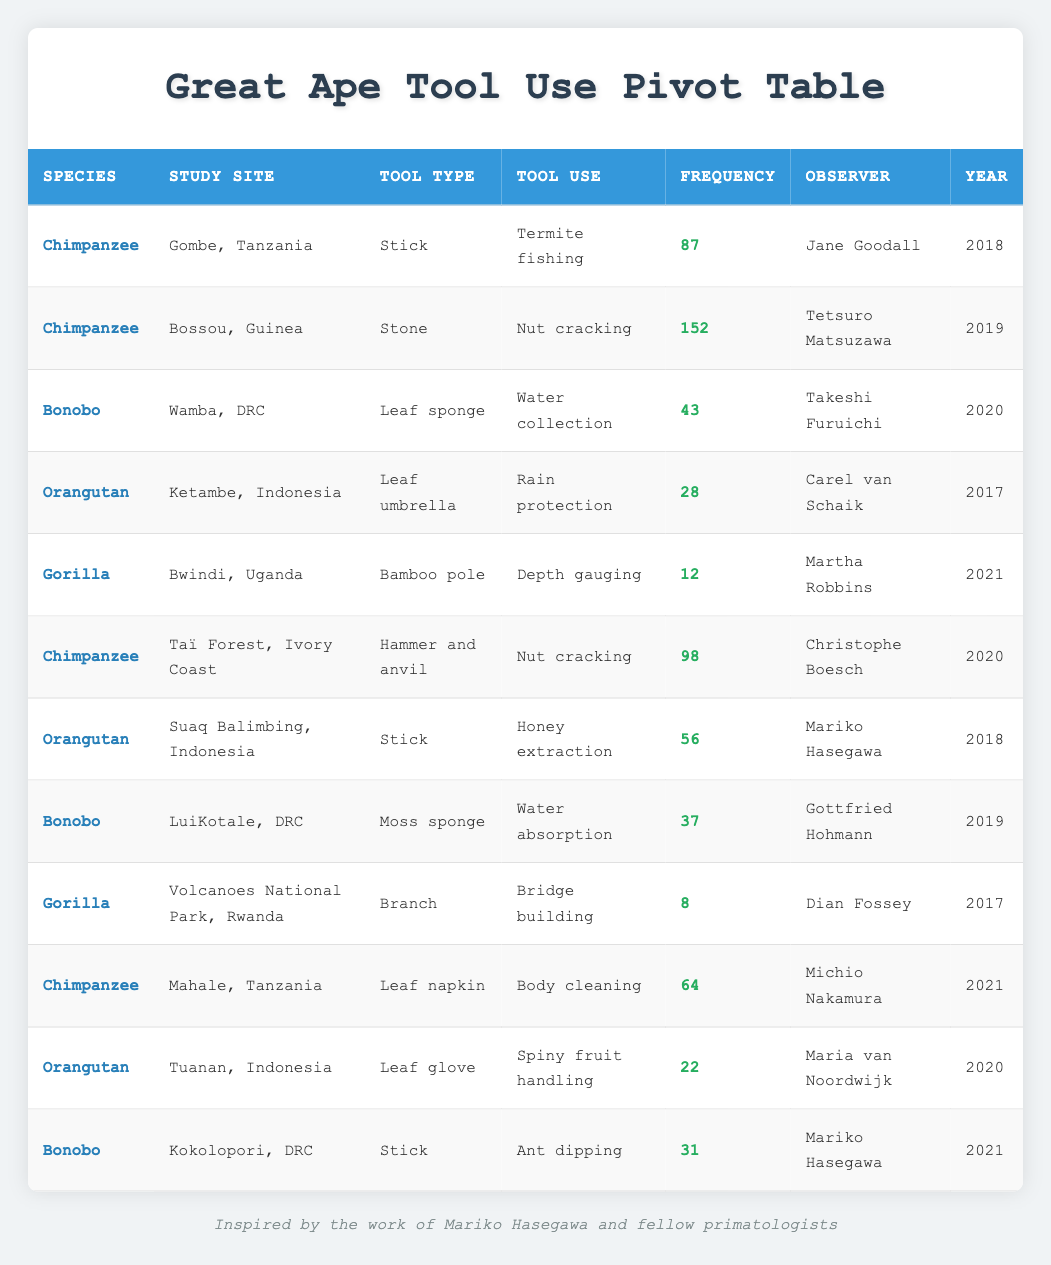What is the frequency of tool use for Chimpanzees observed in Gombe, Tanzania? The data shows that there is one entry for Chimpanzees in Gombe, Tanzania, with a frequency of 87. This value is directly listed in the table under the respective row for this species and study site.
Answer: 87 What tool use was observed for Bonobos at LuiKotale, DRC? According to the table, Bonobos at LuiKotale used a moss sponge for water absorption. This information can be found in the corresponding row for Bonobos in the specified study site.
Answer: Water absorption Which species had the highest recorded frequency of tool use and what was that frequency? By examining the frequency values in the table, the highest recorded frequency is 152 for Chimpanzees using stones for nut cracking in Bossou, Guinea. This can be identified by comparing all the frequency values.
Answer: 152 for Chimpanzees How many different types of tools were used by Orangutans based on the data? The table lists three instances of tool use for Orangutans: leaf umbrella for rain protection, stick for honey extraction, and leaf glove for spiny fruit handling. Each entry represents a unique type of tool, so the total is counted by identifying distinct tool types associated with the Orangutan species.
Answer: 3 What is the total frequency of tool use by Bonobos across all study sites? To find the total frequency of tool use by Bonobos, the frequencies listed for each entry concerning Bonobos must be summed up: 43 (Wamba) + 37 (LuiKotale) + 31 (Kokolopori) = 111. This requires locating all rows with Bonobos and performing the addition of their frequencies.
Answer: 111 Did any observer document tool use by Gorillas in the study? Yes, there are two entries in the table for Gorilla tool use: one for depth gauging with a bamboo pole and another for bridge building using a branch. This can be determined by checking the 'Observer' column for any Gorilla entries in the table.
Answer: Yes What is the average frequency of tool use for Chimpanzees across all entries? There are four entries for Chimpanzees with frequencies 87, 152, 98, and 64. First, summing these values gives 401. Since there are 4 entries, the average frequency is calculated by dividing the total frequency by the number of entries: 401 / 4 = 100.25. This calculation shows the average across all Chimpanzee observations.
Answer: 100.25 Was "stick" the most frequently used tool type across all species? No, the most frequently used tool type based on the frequency values is actually the "stone" used by Chimpanzees for nut cracking, which has the highest frequency of 152. "Stick" is used by various species but does not exceed this value. This comparison can be made by analyzing all frequency entries for the different tool types.
Answer: No How many tools were used for nut cracking and what were their frequencies? There are two recorded tool uses for nut cracking: one by Chimpanzees using a stone with a frequency of 152 and another using a hammer and anvil with a frequency of 98. Indicating the total frequency for nut cracking would require identifying both entries and listing their respective frequencies.
Answer: 252 (152 + 98) 